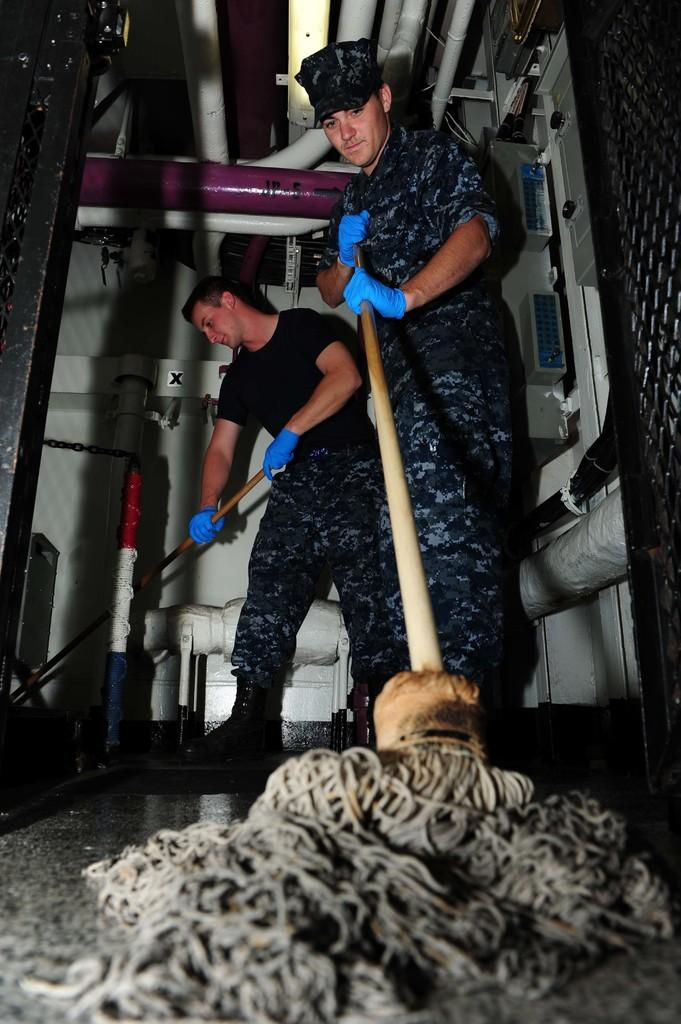How many people are in the image? There are two persons standing in the image. What are the people holding in their hands? One person is holding a mop stick, and another person is holding a stick. What can be seen in the background of the image? There are pipes visible in the background of the image. What type of hand can be seen holding the whistle in the image? There is no hand or whistle present in the image. What material is the plastic used for in the image? There is no plastic mentioned or visible in the image. 